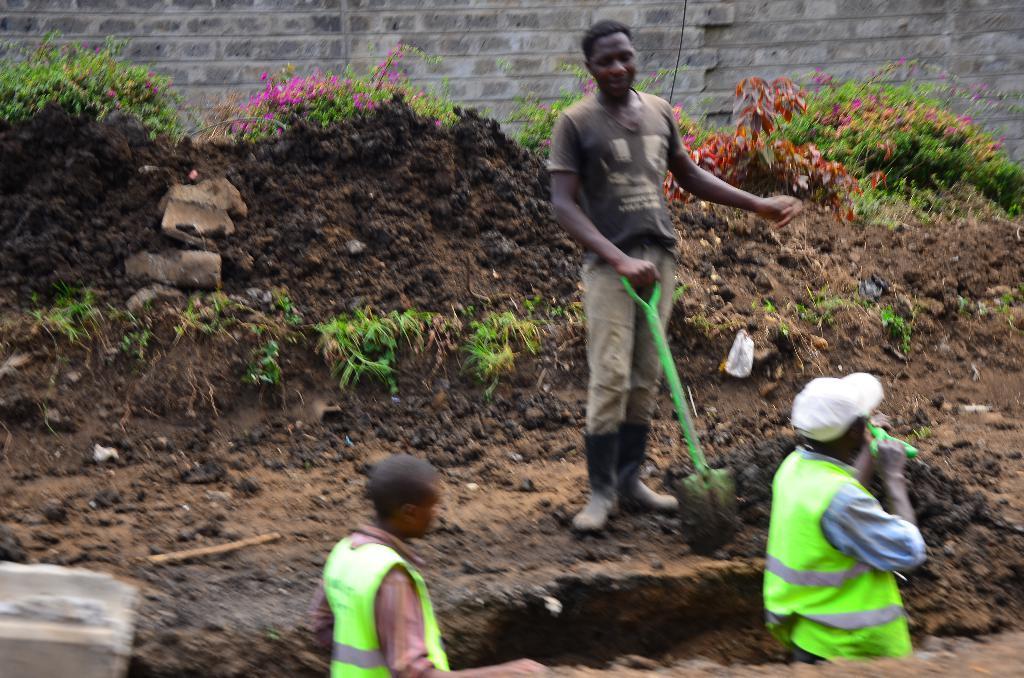In one or two sentences, can you explain what this image depicts? In this image in the foreground I can see two people and in the middle I can see a person holding spade and there are many plants around and in the background I can see the wall. 